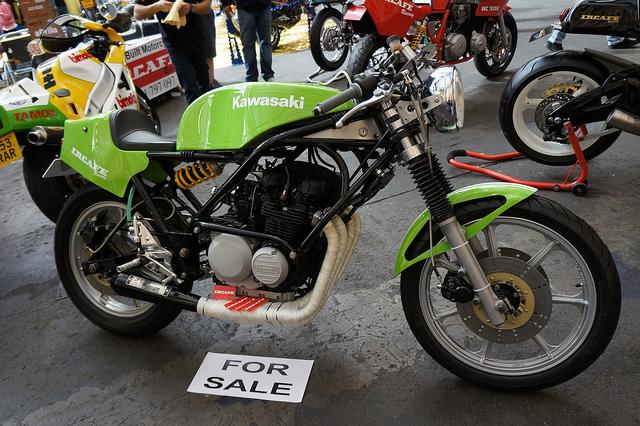What model of bike is this?
Concise answer only. Kawasaki. What does the sign say on the ground?
Short answer required. For sale. What kind of motorcycle is this?
Keep it brief. Kawasaki. Are these motorcycles for racing?
Be succinct. Yes. Is there more than one motorcycle in the scene?
Concise answer only. Yes. What is the total of the 2 numbers?
Short answer required. 2. What color is the bike?
Answer briefly. Green. How many different brands?
Quick response, please. 3. How many motorcycles are in this image?
Quick response, please. 3. 